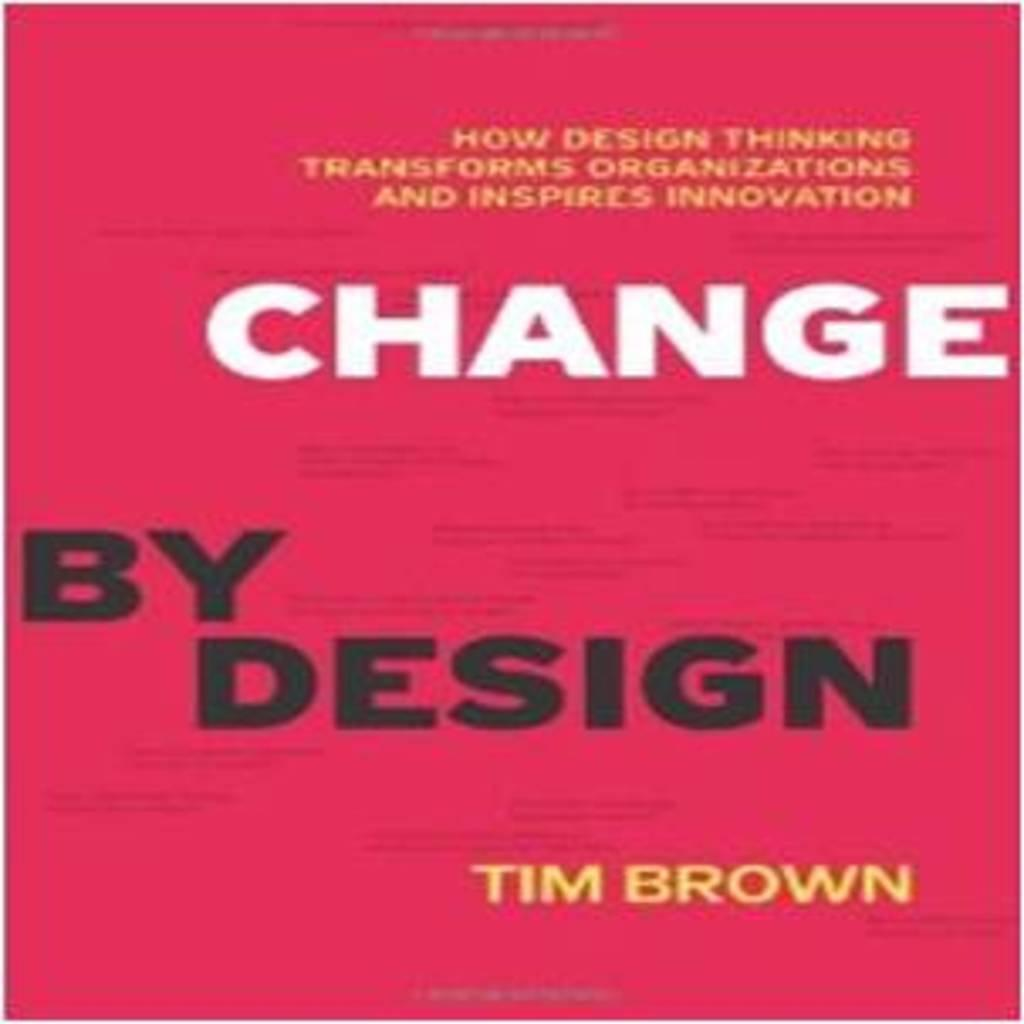<image>
Give a short and clear explanation of the subsequent image. Change by Design label that is presented by Tim Brown. 